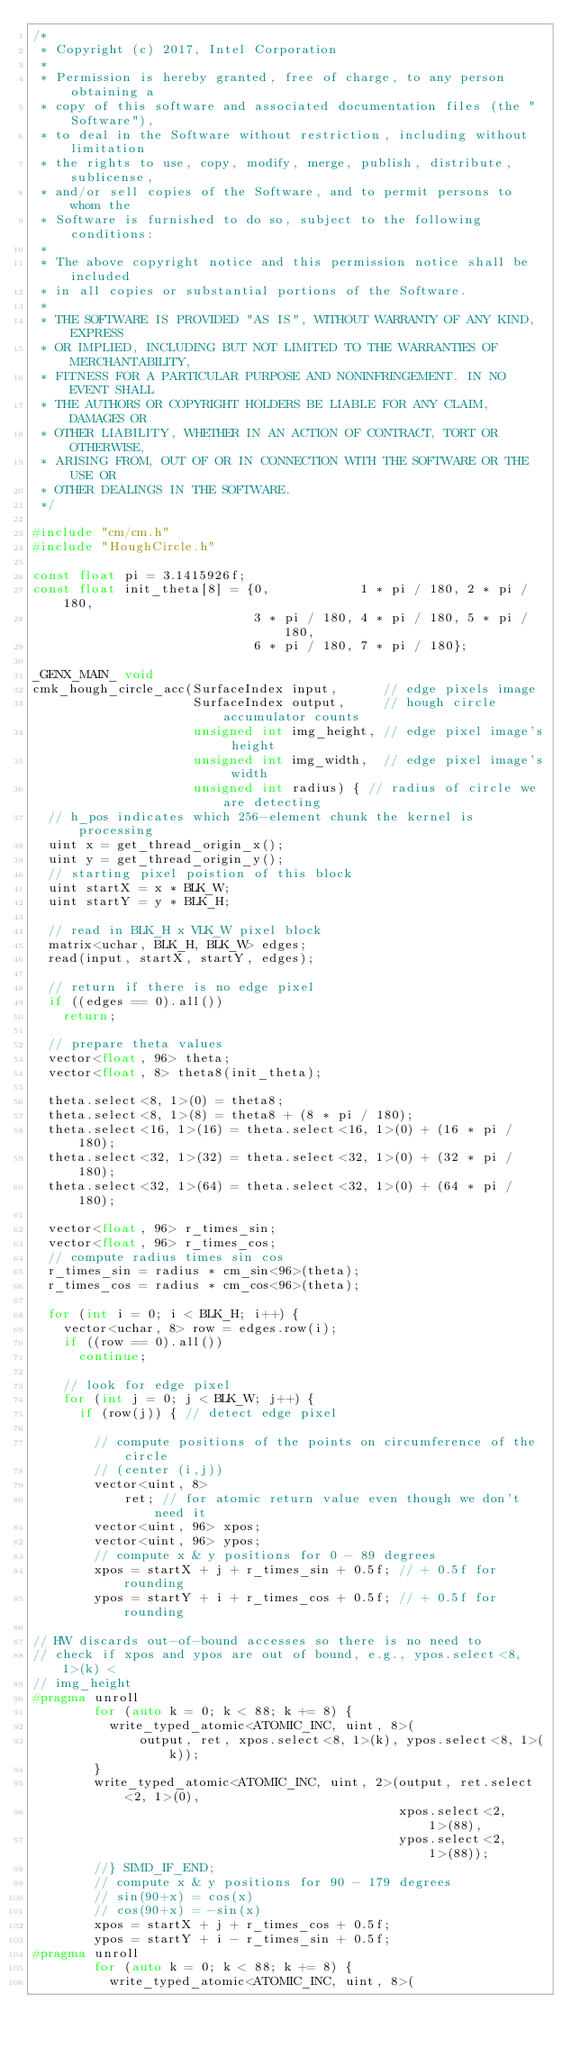<code> <loc_0><loc_0><loc_500><loc_500><_C++_>/*
 * Copyright (c) 2017, Intel Corporation
 *
 * Permission is hereby granted, free of charge, to any person obtaining a
 * copy of this software and associated documentation files (the "Software"),
 * to deal in the Software without restriction, including without limitation
 * the rights to use, copy, modify, merge, publish, distribute, sublicense,
 * and/or sell copies of the Software, and to permit persons to whom the
 * Software is furnished to do so, subject to the following conditions:
 *
 * The above copyright notice and this permission notice shall be included
 * in all copies or substantial portions of the Software.
 *
 * THE SOFTWARE IS PROVIDED "AS IS", WITHOUT WARRANTY OF ANY KIND, EXPRESS
 * OR IMPLIED, INCLUDING BUT NOT LIMITED TO THE WARRANTIES OF MERCHANTABILITY,
 * FITNESS FOR A PARTICULAR PURPOSE AND NONINFRINGEMENT. IN NO EVENT SHALL
 * THE AUTHORS OR COPYRIGHT HOLDERS BE LIABLE FOR ANY CLAIM, DAMAGES OR
 * OTHER LIABILITY, WHETHER IN AN ACTION OF CONTRACT, TORT OR OTHERWISE,
 * ARISING FROM, OUT OF OR IN CONNECTION WITH THE SOFTWARE OR THE USE OR
 * OTHER DEALINGS IN THE SOFTWARE.
 */

#include "cm/cm.h"
#include "HoughCircle.h"

const float pi = 3.1415926f;
const float init_theta[8] = {0,            1 * pi / 180, 2 * pi / 180,
                             3 * pi / 180, 4 * pi / 180, 5 * pi / 180,
                             6 * pi / 180, 7 * pi / 180};

_GENX_MAIN_ void
cmk_hough_circle_acc(SurfaceIndex input,      // edge pixels image
                     SurfaceIndex output,     // hough circle accumulator counts
                     unsigned int img_height, // edge pixel image's height
                     unsigned int img_width,  // edge pixel image's width
                     unsigned int radius) { // radius of circle we are detecting
  // h_pos indicates which 256-element chunk the kernel is processing
  uint x = get_thread_origin_x();
  uint y = get_thread_origin_y();
  // starting pixel poistion of this block
  uint startX = x * BLK_W;
  uint startY = y * BLK_H;

  // read in BLK_H x VLK_W pixel block
  matrix<uchar, BLK_H, BLK_W> edges;
  read(input, startX, startY, edges);

  // return if there is no edge pixel
  if ((edges == 0).all())
    return;

  // prepare theta values
  vector<float, 96> theta;
  vector<float, 8> theta8(init_theta);

  theta.select<8, 1>(0) = theta8;
  theta.select<8, 1>(8) = theta8 + (8 * pi / 180);
  theta.select<16, 1>(16) = theta.select<16, 1>(0) + (16 * pi / 180);
  theta.select<32, 1>(32) = theta.select<32, 1>(0) + (32 * pi / 180);
  theta.select<32, 1>(64) = theta.select<32, 1>(0) + (64 * pi / 180);

  vector<float, 96> r_times_sin;
  vector<float, 96> r_times_cos;
  // compute radius times sin cos
  r_times_sin = radius * cm_sin<96>(theta);
  r_times_cos = radius * cm_cos<96>(theta);

  for (int i = 0; i < BLK_H; i++) {
    vector<uchar, 8> row = edges.row(i);
    if ((row == 0).all())
      continue;

    // look for edge pixel
    for (int j = 0; j < BLK_W; j++) {
      if (row(j)) { // detect edge pixel

        // compute positions of the points on circumference of the circle
        // (center (i,j))
        vector<uint, 8>
            ret; // for atomic return value even though we don't need it
        vector<uint, 96> xpos;
        vector<uint, 96> ypos;
        // compute x & y positions for 0 - 89 degrees
        xpos = startX + j + r_times_sin + 0.5f; // + 0.5f for rounding
        ypos = startY + i + r_times_cos + 0.5f; // + 0.5f for rounding

// HW discards out-of-bound accesses so there is no need to
// check if xpos and ypos are out of bound, e.g., ypos.select<8, 1>(k) <
// img_height
#pragma unroll
        for (auto k = 0; k < 88; k += 8) {
          write_typed_atomic<ATOMIC_INC, uint, 8>(
              output, ret, xpos.select<8, 1>(k), ypos.select<8, 1>(k));
        }
        write_typed_atomic<ATOMIC_INC, uint, 2>(output, ret.select<2, 1>(0),
                                                xpos.select<2, 1>(88),
                                                ypos.select<2, 1>(88));
        //} SIMD_IF_END;
        // compute x & y positions for 90 - 179 degrees
        // sin(90+x) = cos(x)
        // cos(90+x) = -sin(x)
        xpos = startX + j + r_times_cos + 0.5f;
        ypos = startY + i - r_times_sin + 0.5f;
#pragma unroll
        for (auto k = 0; k < 88; k += 8) {
          write_typed_atomic<ATOMIC_INC, uint, 8>(</code> 